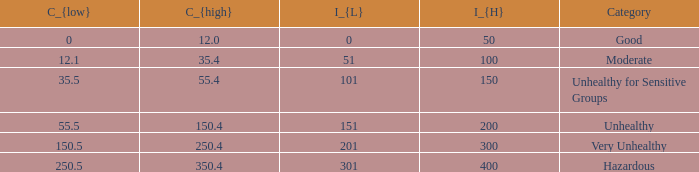What's the C_{low} value when C_{high} is 12.0? 0.0. 